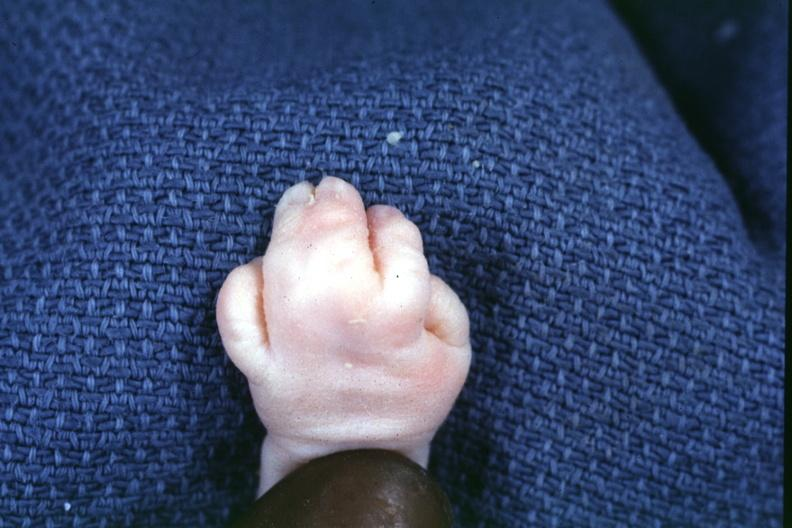s very good example present?
Answer the question using a single word or phrase. No 